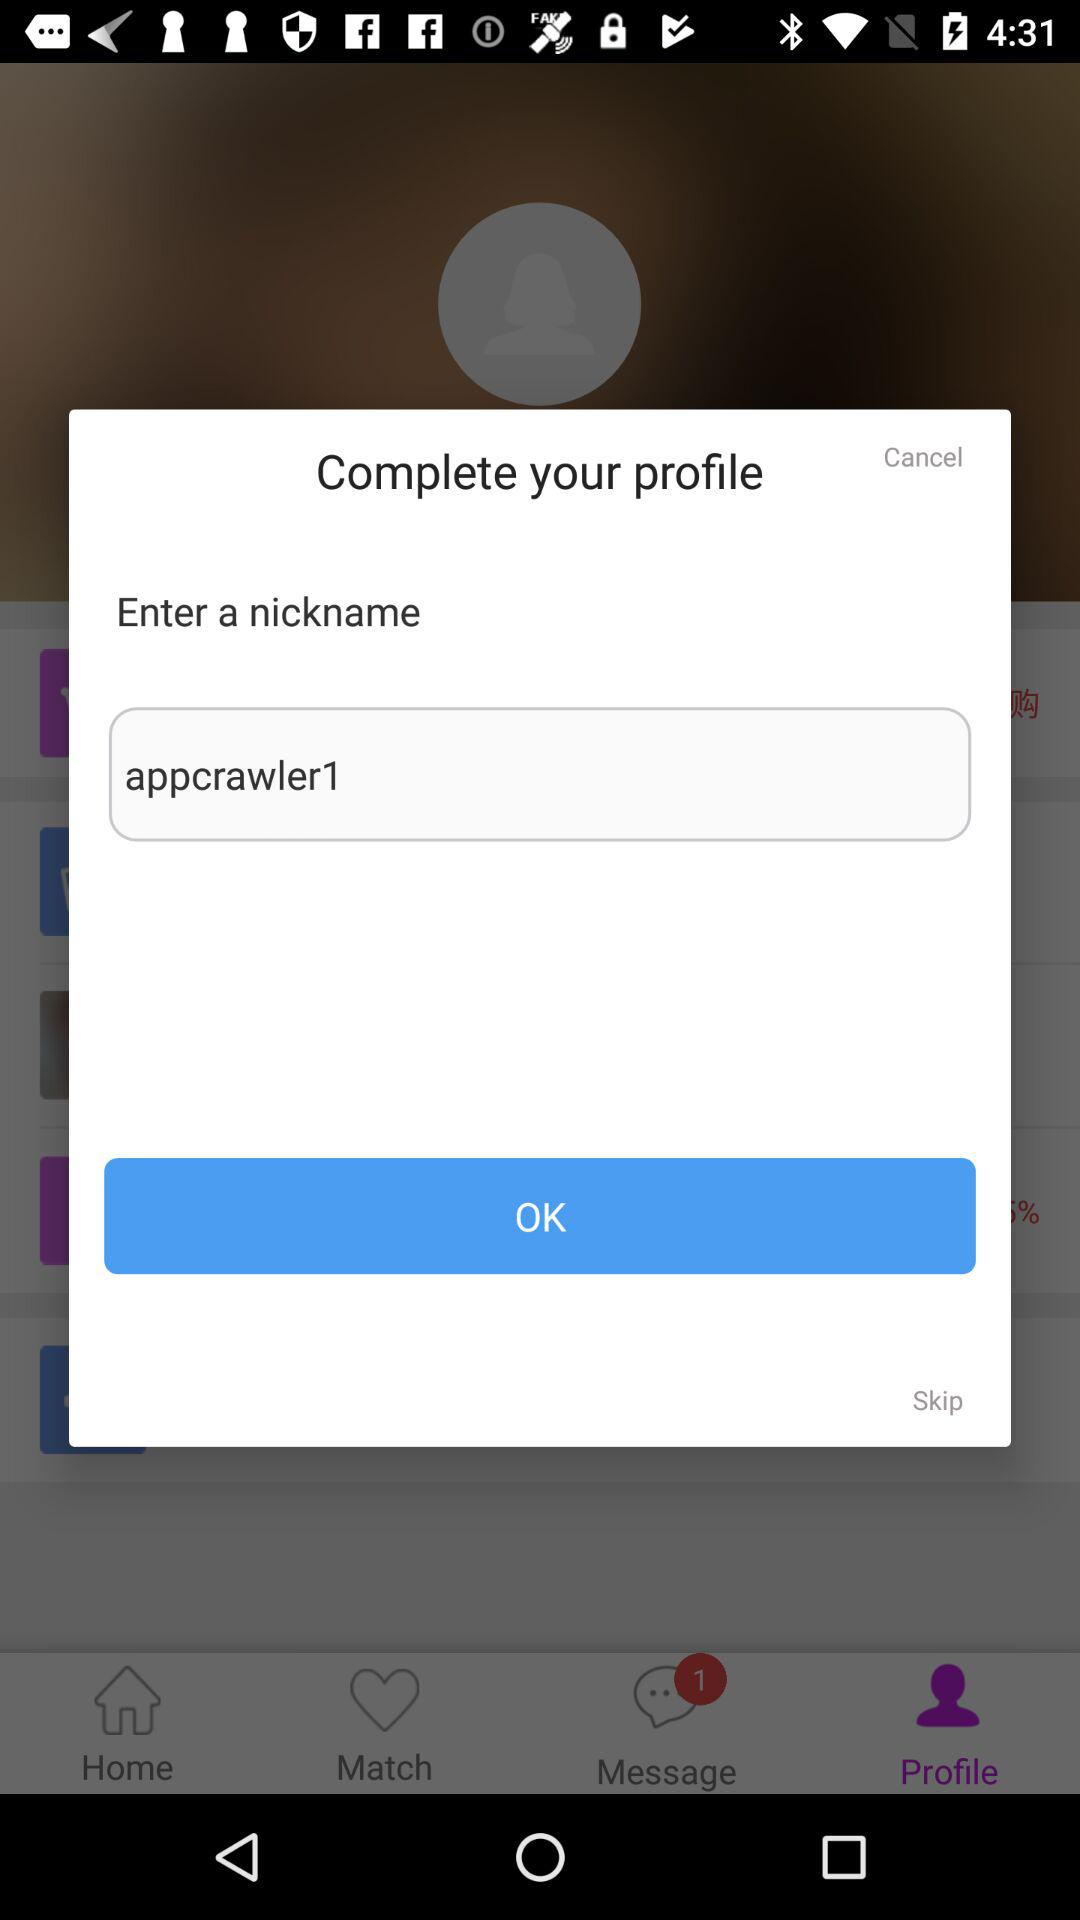Is there any unread chat? There is 1 unread chat. 